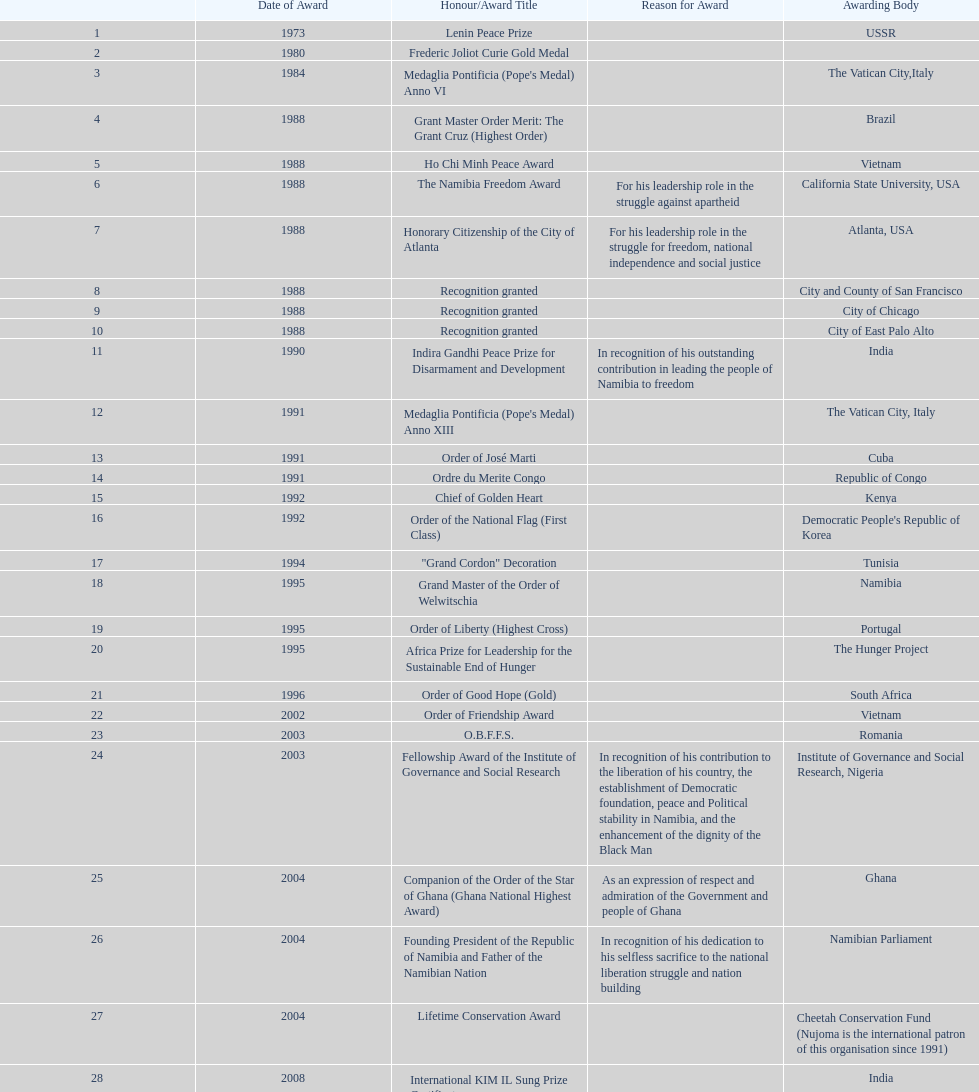What is the difference between the number of awards won in 1988 and the number of awards won in 1995? 4. 